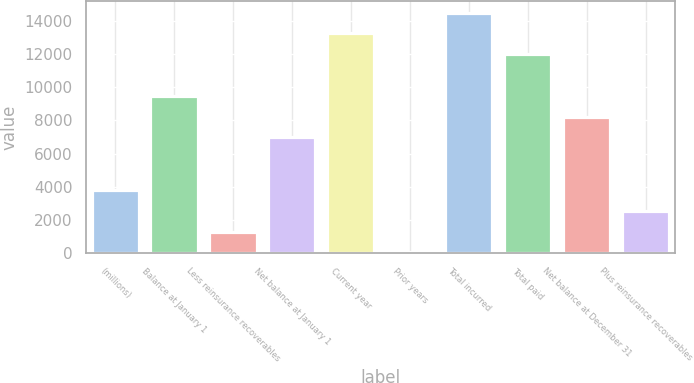Convert chart. <chart><loc_0><loc_0><loc_500><loc_500><bar_chart><fcel>(millions)<fcel>Balance at January 1<fcel>Less reinsurance recoverables<fcel>Net balance at January 1<fcel>Current year<fcel>Prior years<fcel>Total incurred<fcel>Total paid<fcel>Net balance at December 31<fcel>Plus reinsurance recoverables<nl><fcel>3773.29<fcel>9461.76<fcel>1287.83<fcel>6976.3<fcel>13257.6<fcel>45.1<fcel>14500.4<fcel>12014.9<fcel>8219.03<fcel>2530.56<nl></chart> 